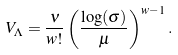Convert formula to latex. <formula><loc_0><loc_0><loc_500><loc_500>V _ { \Lambda } = \frac { \nu } { w ! } \left ( \frac { \log ( \sigma ) } { \mu } \right ) ^ { w - 1 } .</formula> 